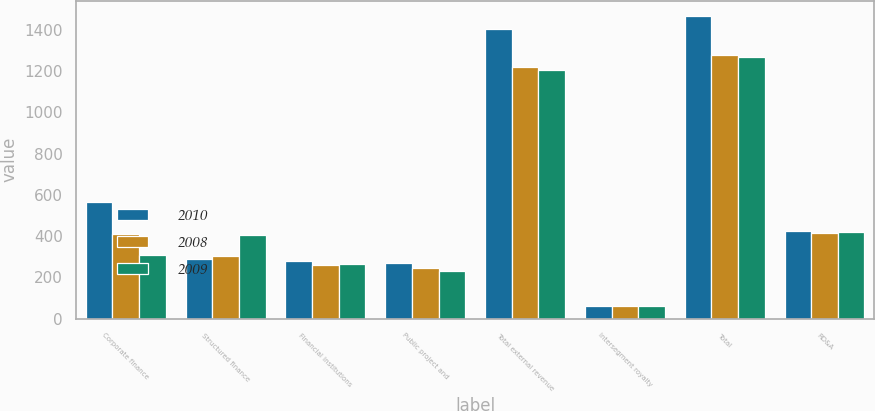Convert chart. <chart><loc_0><loc_0><loc_500><loc_500><stacked_bar_chart><ecel><fcel>Corporate finance<fcel>Structured finance<fcel>Financial institutions<fcel>Public project and<fcel>Total external revenue<fcel>Intersegment royalty<fcel>Total<fcel>RD&A<nl><fcel>2010<fcel>563.9<fcel>290.8<fcel>278.7<fcel>271.6<fcel>1405<fcel>61.3<fcel>1466.3<fcel>425<nl><fcel>2008<fcel>408.2<fcel>304.9<fcel>258.5<fcel>246.1<fcel>1217.7<fcel>60<fcel>1277.7<fcel>413.6<nl><fcel>2009<fcel>307<fcel>404.7<fcel>263<fcel>230<fcel>1204.7<fcel>63.6<fcel>1268.3<fcel>418.7<nl></chart> 